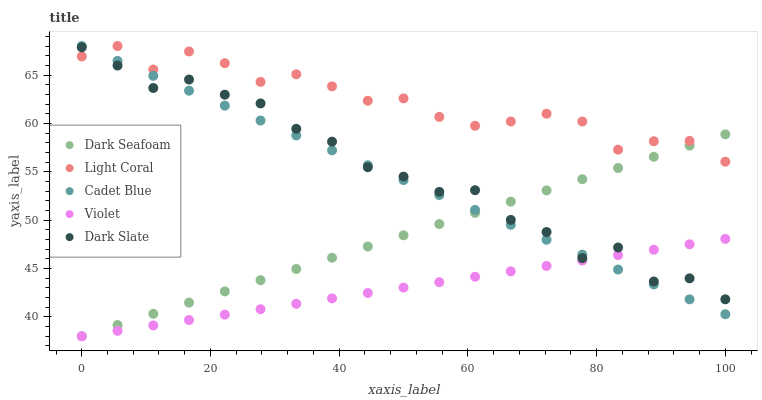Does Violet have the minimum area under the curve?
Answer yes or no. Yes. Does Light Coral have the maximum area under the curve?
Answer yes or no. Yes. Does Dark Slate have the minimum area under the curve?
Answer yes or no. No. Does Dark Slate have the maximum area under the curve?
Answer yes or no. No. Is Dark Seafoam the smoothest?
Answer yes or no. Yes. Is Dark Slate the roughest?
Answer yes or no. Yes. Is Dark Slate the smoothest?
Answer yes or no. No. Is Dark Seafoam the roughest?
Answer yes or no. No. Does Dark Seafoam have the lowest value?
Answer yes or no. Yes. Does Dark Slate have the lowest value?
Answer yes or no. No. Does Cadet Blue have the highest value?
Answer yes or no. Yes. Does Dark Slate have the highest value?
Answer yes or no. No. Is Violet less than Light Coral?
Answer yes or no. Yes. Is Light Coral greater than Violet?
Answer yes or no. Yes. Does Dark Slate intersect Violet?
Answer yes or no. Yes. Is Dark Slate less than Violet?
Answer yes or no. No. Is Dark Slate greater than Violet?
Answer yes or no. No. Does Violet intersect Light Coral?
Answer yes or no. No. 